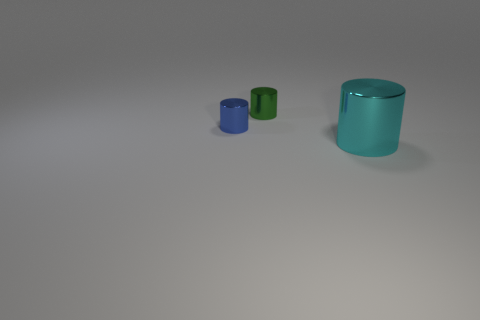What number of other things are there of the same size as the cyan cylinder?
Provide a short and direct response. 0. There is a large cylinder; is its color the same as the tiny cylinder to the right of the small blue object?
Provide a succinct answer. No. What number of objects are either green metallic cylinders or tiny red rubber things?
Offer a very short reply. 1. Is there anything else that is the same color as the big thing?
Ensure brevity in your answer.  No. Are the big cylinder and the small cylinder in front of the tiny green cylinder made of the same material?
Your answer should be very brief. Yes. What shape is the tiny shiny thing that is behind the tiny cylinder in front of the small green metallic thing?
Your answer should be compact. Cylinder. There is a thing that is to the right of the small blue thing and behind the large metallic cylinder; what shape is it?
Keep it short and to the point. Cylinder. What number of things are big cyan metallic things or tiny objects that are in front of the small green cylinder?
Keep it short and to the point. 2. There is a small blue thing that is the same shape as the big metallic thing; what is its material?
Make the answer very short. Metal. Is there any other thing that is made of the same material as the big cyan cylinder?
Ensure brevity in your answer.  Yes. 